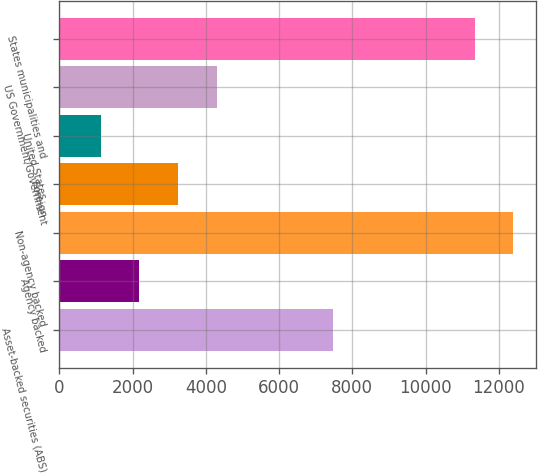<chart> <loc_0><loc_0><loc_500><loc_500><bar_chart><fcel>Asset-backed securities (ABS)<fcel>Agency backed<fcel>Non-agency backed<fcel>Foreign<fcel>United States<fcel>US Government/Government<fcel>States municipalities and<nl><fcel>7469<fcel>2186.4<fcel>12391.4<fcel>3240.8<fcel>1132<fcel>4295.2<fcel>11337<nl></chart> 